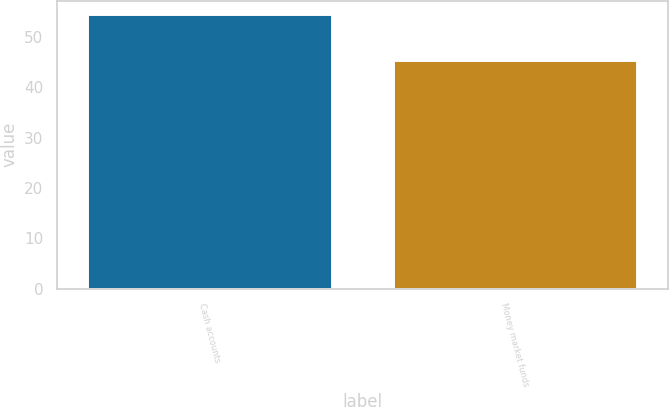Convert chart. <chart><loc_0><loc_0><loc_500><loc_500><bar_chart><fcel>Cash accounts<fcel>Money market funds<nl><fcel>54.5<fcel>45.5<nl></chart> 